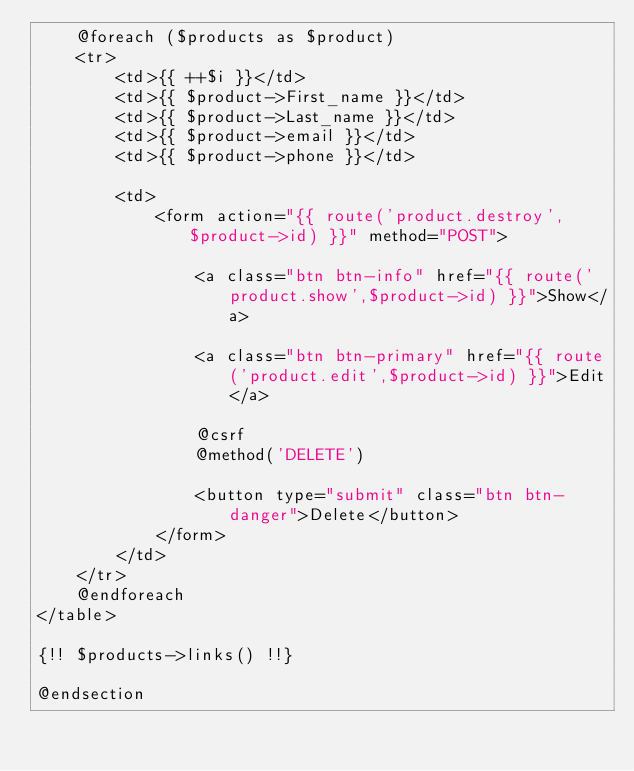<code> <loc_0><loc_0><loc_500><loc_500><_PHP_>    @foreach ($products as $product)
    <tr>
        <td>{{ ++$i }}</td>
        <td>{{ $product->First_name }}</td>
        <td>{{ $product->Last_name }}</td>
        <td>{{ $product->email }}</td>
        <td>{{ $product->phone }}</td>

        <td>
            <form action="{{ route('product.destroy',$product->id) }}" method="POST">

                <a class="btn btn-info" href="{{ route('product.show',$product->id) }}">Show</a>

                <a class="btn btn-primary" href="{{ route('product.edit',$product->id) }}">Edit</a>

                @csrf
                @method('DELETE')

                <button type="submit" class="btn btn-danger">Delete</button>
            </form>
        </td>
    </tr>
    @endforeach
</table>

{!! $products->links() !!}

@endsection</code> 